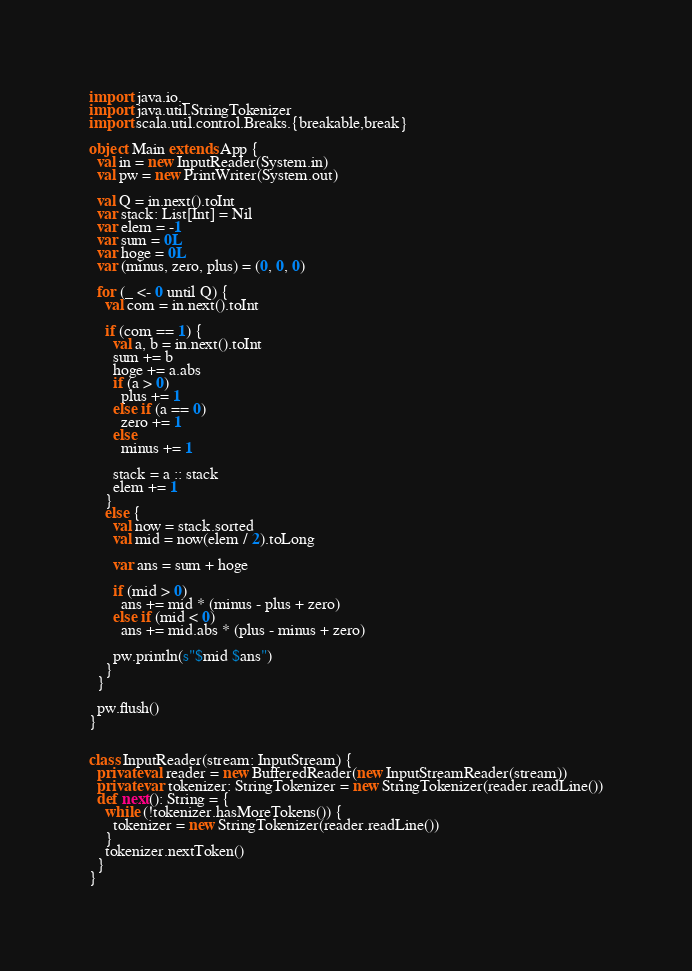<code> <loc_0><loc_0><loc_500><loc_500><_Scala_>import java.io._
import java.util.StringTokenizer
import scala.util.control.Breaks.{breakable,break}

object Main extends App {
  val in = new InputReader(System.in)
  val pw = new PrintWriter(System.out)

  val Q = in.next().toInt
  var stack: List[Int] = Nil
  var elem = -1
  var sum = 0L
  var hoge = 0L
  var (minus, zero, plus) = (0, 0, 0)

  for (_ <- 0 until Q) {
    val com = in.next().toInt

    if (com == 1) {
      val a, b = in.next().toInt
      sum += b
      hoge += a.abs
      if (a > 0)
        plus += 1
      else if (a == 0)
        zero += 1
      else
        minus += 1

      stack = a :: stack
      elem += 1
    }
    else {
      val now = stack.sorted
      val mid = now(elem / 2).toLong

      var ans = sum + hoge
      
      if (mid > 0)
        ans += mid * (minus - plus + zero)
      else if (mid < 0)
        ans += mid.abs * (plus - minus + zero)

      pw.println(s"$mid $ans")
    }
  }

  pw.flush()
}


class InputReader(stream: InputStream) {
  private val reader = new BufferedReader(new InputStreamReader(stream))
  private var tokenizer: StringTokenizer = new StringTokenizer(reader.readLine())
  def next(): String = {
    while (!tokenizer.hasMoreTokens()) {
      tokenizer = new StringTokenizer(reader.readLine())
    }
    tokenizer.nextToken()
  }
}
</code> 